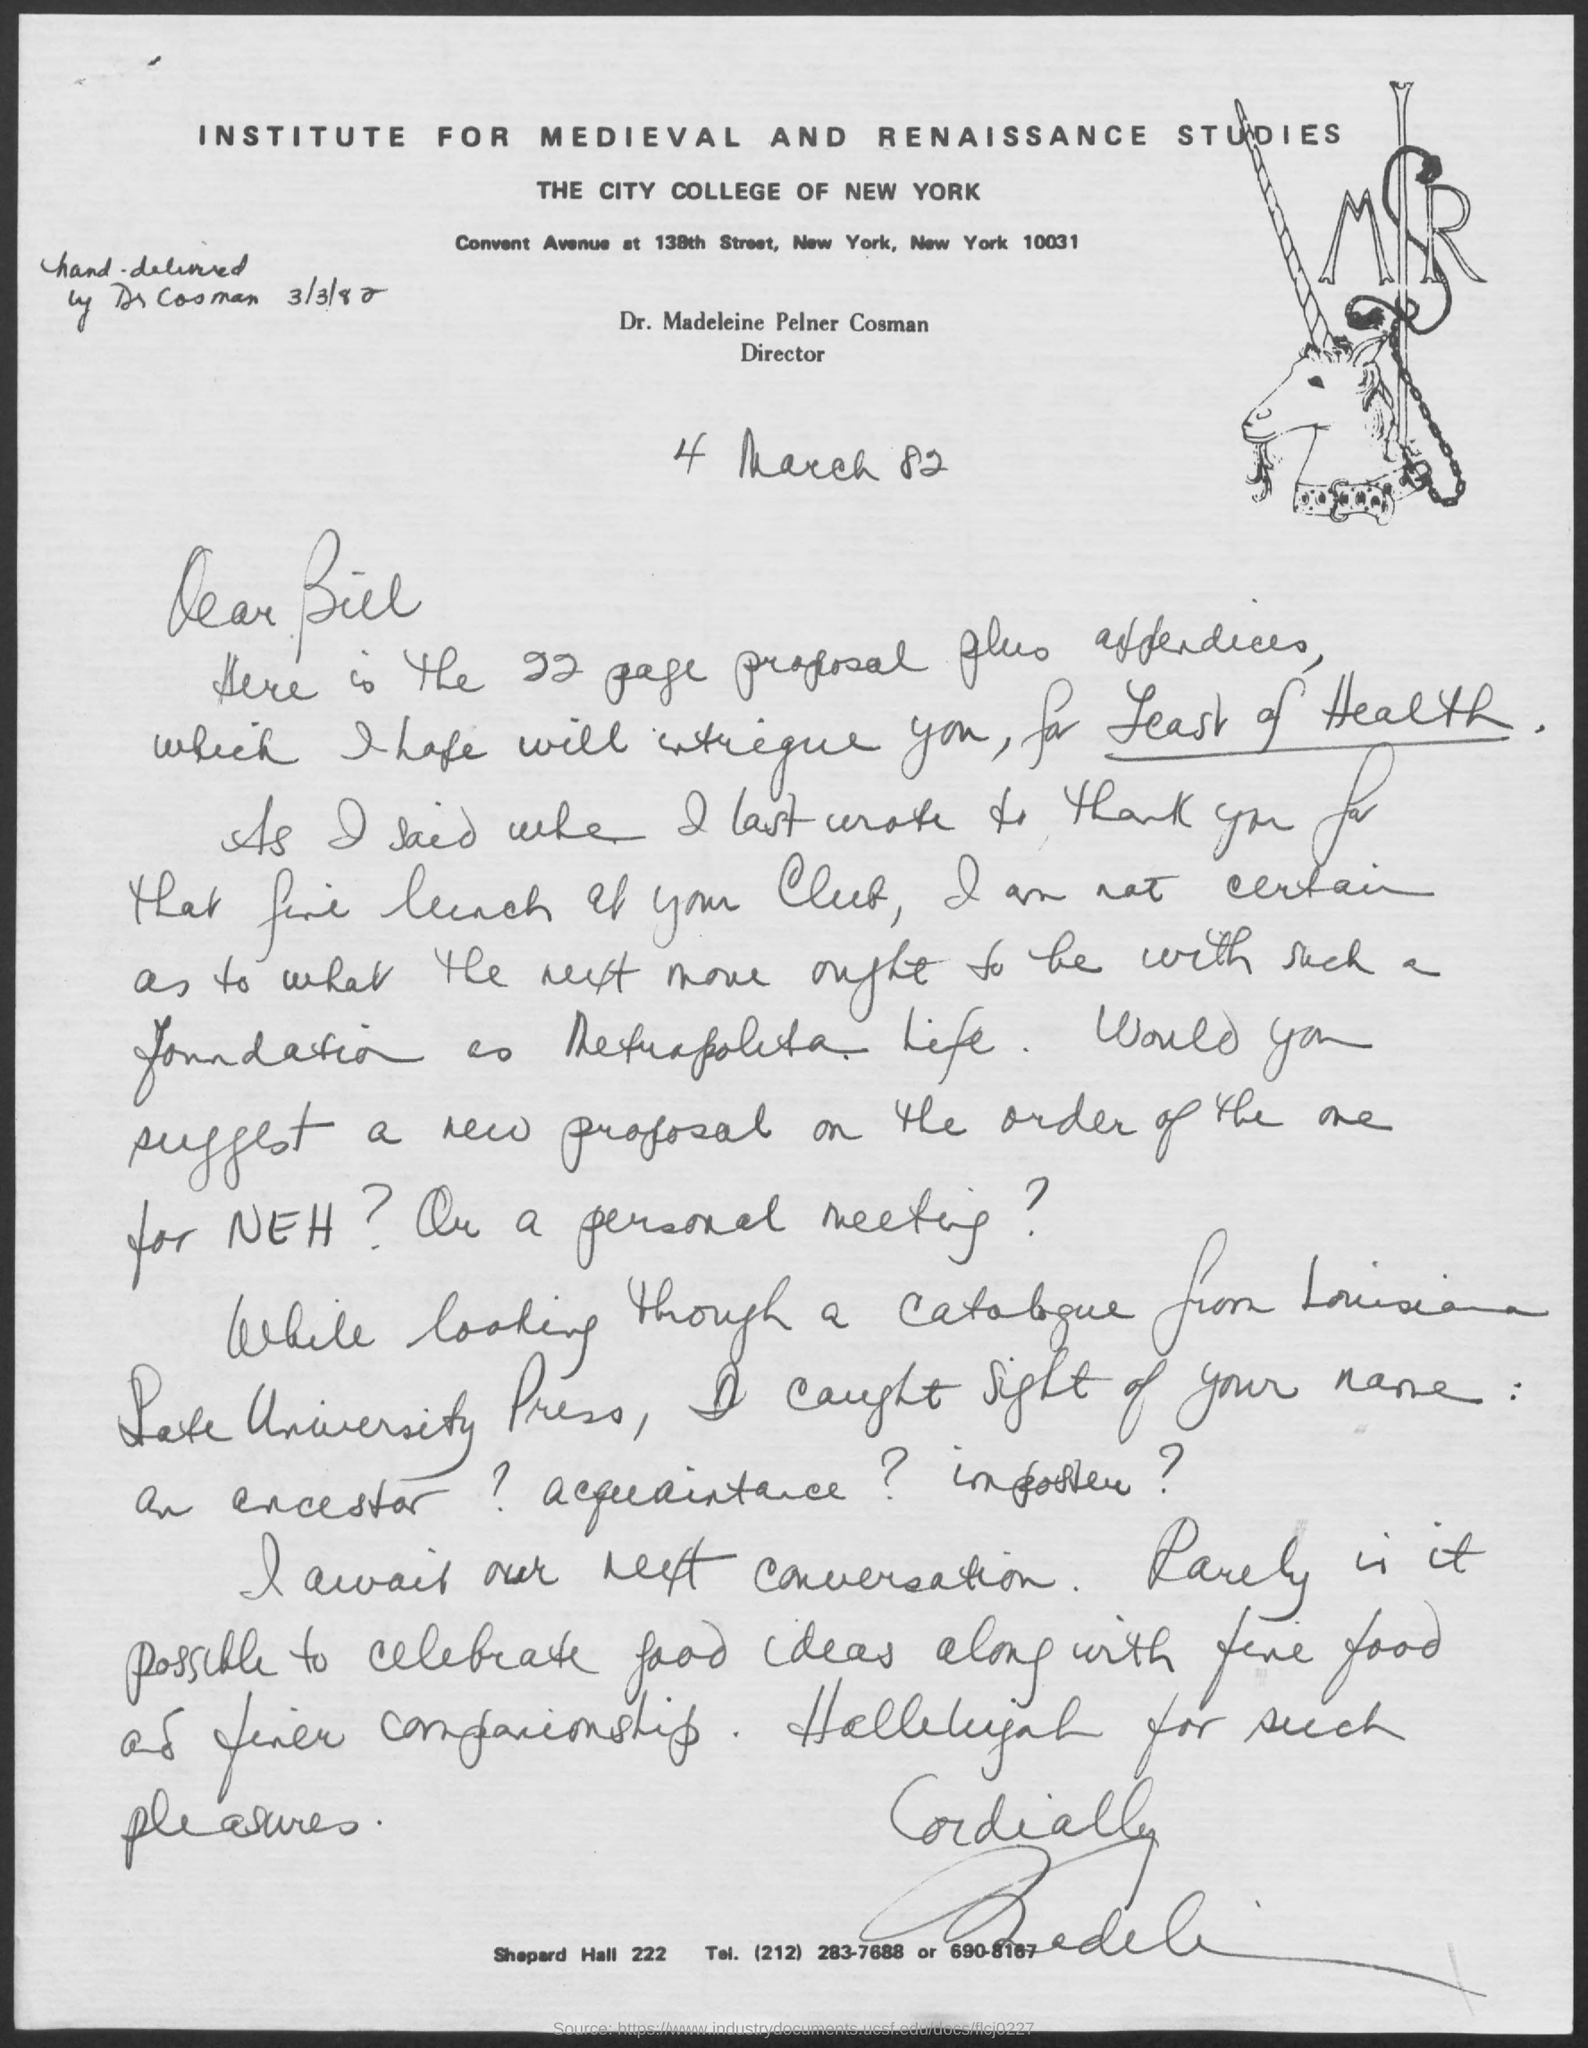Which institute is mentioned at the top of the page?
Your answer should be very brief. INSTITUTE FOR MEDIEVAL AND RENAISSANCE STUDIES. Which College is mentioned?
Provide a succinct answer. THE CITY COLLEGE OF NEW YORK. Who is the director?
Your response must be concise. Dr. Madeleine Pelner Cosman. When was the letter hand-delivered by Dr Cosman?
Offer a very short reply. 3/3/82. 